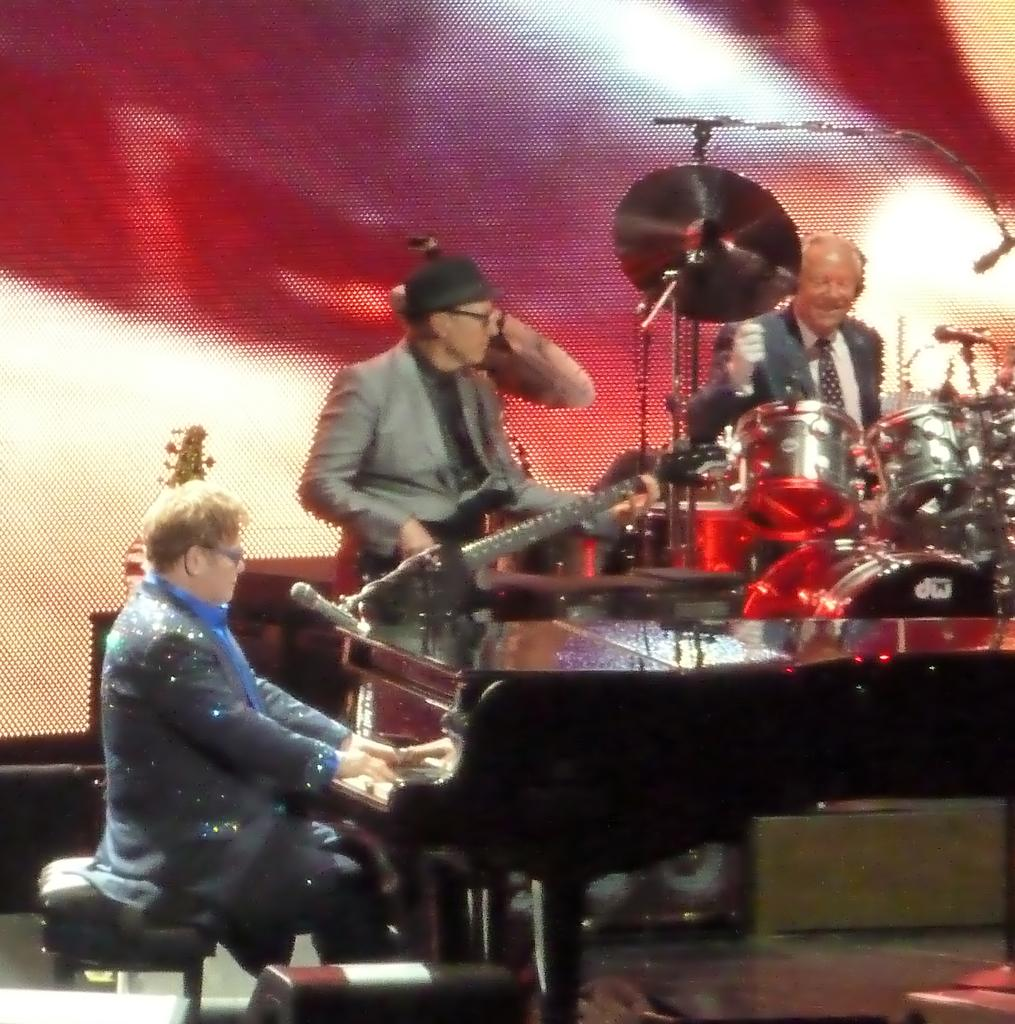What are the people in the image doing? The people in the image are playing musical instruments. What can be seen in the background of the image? There is a screen and microphones placed on stands in the background of the image. Where can the fairies be found in the image? There are no fairies present in the image. What type of jam is being served at the station in the image? There is no station or jam present in the image. 